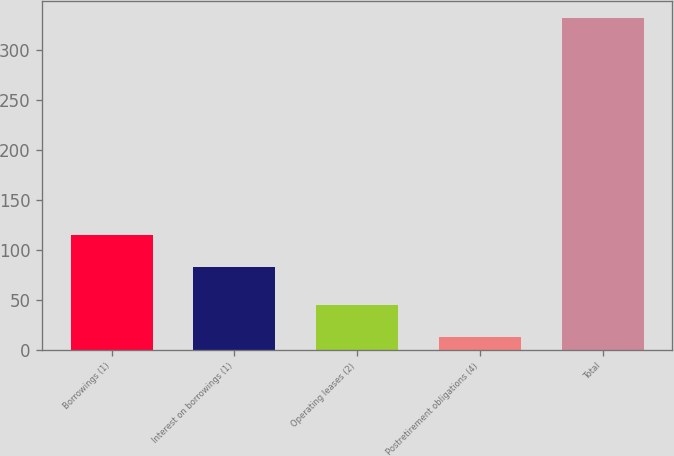Convert chart to OTSL. <chart><loc_0><loc_0><loc_500><loc_500><bar_chart><fcel>Borrowings (1)<fcel>Interest on borrowings (1)<fcel>Operating leases (2)<fcel>Postretirement obligations (4)<fcel>Total<nl><fcel>114.9<fcel>83<fcel>45<fcel>13<fcel>332<nl></chart> 